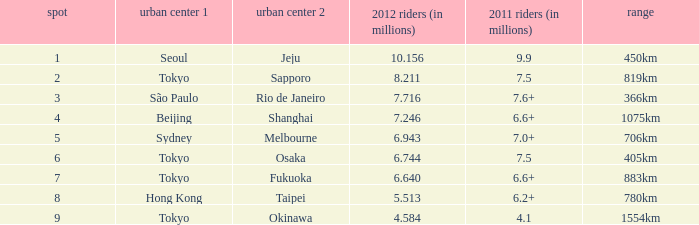How many passengers (in millions) flew from Seoul in 2012? 10.156. 